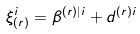Convert formula to latex. <formula><loc_0><loc_0><loc_500><loc_500>\xi ^ { i } _ { ( r ) } = \beta ^ { ( r ) | i } + d ^ { ( r ) i }</formula> 